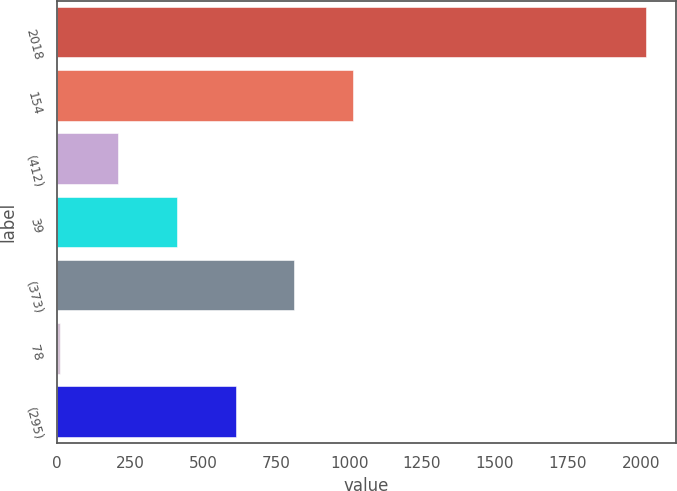Convert chart. <chart><loc_0><loc_0><loc_500><loc_500><bar_chart><fcel>2018<fcel>154<fcel>(412)<fcel>39<fcel>(373)<fcel>78<fcel>(295)<nl><fcel>2018<fcel>1013.5<fcel>209.9<fcel>410.8<fcel>812.6<fcel>9<fcel>611.7<nl></chart> 